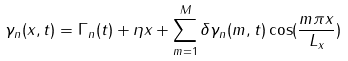<formula> <loc_0><loc_0><loc_500><loc_500>\gamma _ { n } ( x , t ) = \Gamma _ { n } ( t ) + \eta x + \sum _ { m = 1 } ^ { M } \delta \gamma _ { n } ( m , t ) \cos ( \frac { m \pi x } { L _ { x } } )</formula> 